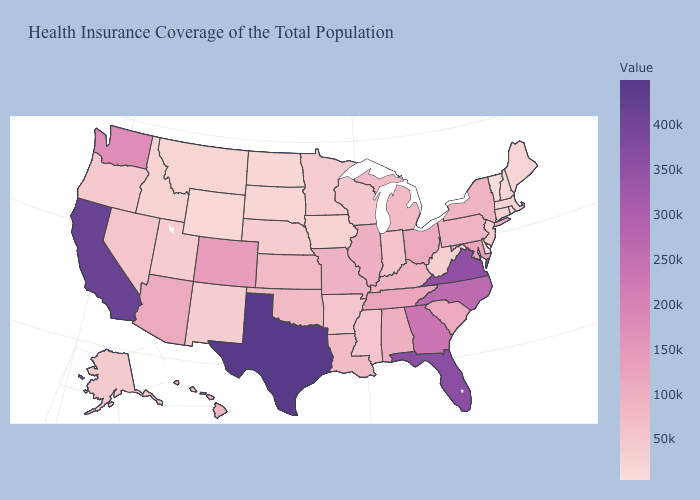Does Mississippi have the highest value in the USA?
Be succinct. No. Which states have the highest value in the USA?
Write a very short answer. Texas. Which states hav the highest value in the South?
Keep it brief. Texas. Among the states that border Tennessee , which have the lowest value?
Concise answer only. Mississippi. Among the states that border South Dakota , which have the lowest value?
Quick response, please. Wyoming. Among the states that border Minnesota , does North Dakota have the lowest value?
Be succinct. Yes. Does Missouri have the lowest value in the USA?
Short answer required. No. Which states hav the highest value in the West?
Give a very brief answer. California. 